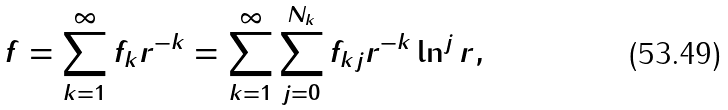Convert formula to latex. <formula><loc_0><loc_0><loc_500><loc_500>f = \sum ^ { \infty } _ { k = 1 } f _ { k } r ^ { - k } = \sum ^ { \infty } _ { k = 1 } \sum _ { j = 0 } ^ { N _ { k } } f _ { k j } r ^ { - k } \ln ^ { j } r ,</formula> 